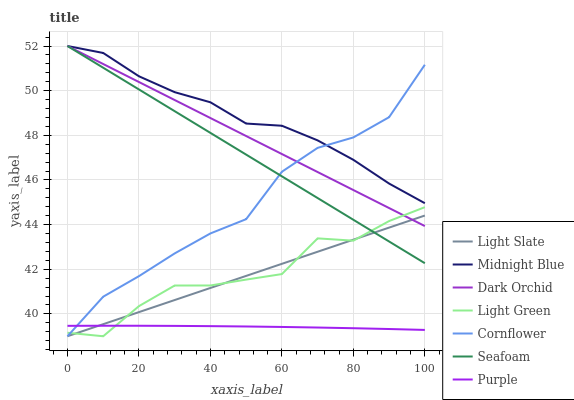Does Purple have the minimum area under the curve?
Answer yes or no. Yes. Does Midnight Blue have the maximum area under the curve?
Answer yes or no. Yes. Does Light Slate have the minimum area under the curve?
Answer yes or no. No. Does Light Slate have the maximum area under the curve?
Answer yes or no. No. Is Seafoam the smoothest?
Answer yes or no. Yes. Is Light Green the roughest?
Answer yes or no. Yes. Is Midnight Blue the smoothest?
Answer yes or no. No. Is Midnight Blue the roughest?
Answer yes or no. No. Does Cornflower have the lowest value?
Answer yes or no. Yes. Does Midnight Blue have the lowest value?
Answer yes or no. No. Does Dark Orchid have the highest value?
Answer yes or no. Yes. Does Light Slate have the highest value?
Answer yes or no. No. Is Purple less than Dark Orchid?
Answer yes or no. Yes. Is Midnight Blue greater than Light Green?
Answer yes or no. Yes. Does Purple intersect Cornflower?
Answer yes or no. Yes. Is Purple less than Cornflower?
Answer yes or no. No. Is Purple greater than Cornflower?
Answer yes or no. No. Does Purple intersect Dark Orchid?
Answer yes or no. No. 